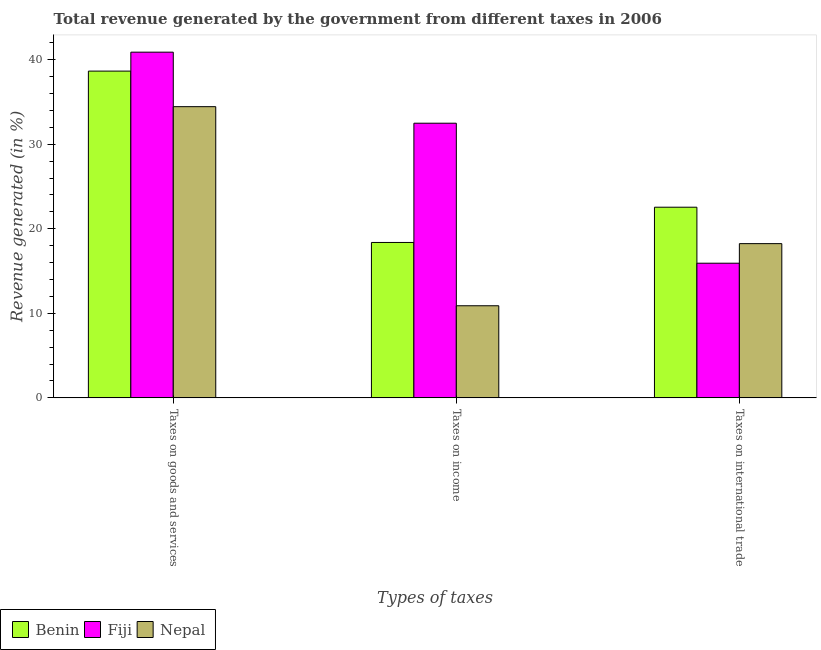How many groups of bars are there?
Your answer should be compact. 3. Are the number of bars per tick equal to the number of legend labels?
Make the answer very short. Yes. Are the number of bars on each tick of the X-axis equal?
Offer a very short reply. Yes. How many bars are there on the 1st tick from the right?
Give a very brief answer. 3. What is the label of the 2nd group of bars from the left?
Your answer should be compact. Taxes on income. What is the percentage of revenue generated by taxes on income in Fiji?
Keep it short and to the point. 32.49. Across all countries, what is the maximum percentage of revenue generated by taxes on income?
Your answer should be very brief. 32.49. Across all countries, what is the minimum percentage of revenue generated by tax on international trade?
Your answer should be compact. 15.93. In which country was the percentage of revenue generated by tax on international trade maximum?
Your answer should be very brief. Benin. In which country was the percentage of revenue generated by taxes on income minimum?
Your answer should be very brief. Nepal. What is the total percentage of revenue generated by taxes on income in the graph?
Provide a short and direct response. 61.76. What is the difference between the percentage of revenue generated by tax on international trade in Nepal and that in Benin?
Provide a short and direct response. -4.31. What is the difference between the percentage of revenue generated by tax on international trade in Nepal and the percentage of revenue generated by taxes on income in Fiji?
Keep it short and to the point. -14.24. What is the average percentage of revenue generated by taxes on goods and services per country?
Provide a short and direct response. 38. What is the difference between the percentage of revenue generated by tax on international trade and percentage of revenue generated by taxes on income in Nepal?
Provide a succinct answer. 7.35. What is the ratio of the percentage of revenue generated by taxes on goods and services in Fiji to that in Nepal?
Give a very brief answer. 1.19. Is the difference between the percentage of revenue generated by tax on international trade in Fiji and Nepal greater than the difference between the percentage of revenue generated by taxes on income in Fiji and Nepal?
Your answer should be very brief. No. What is the difference between the highest and the second highest percentage of revenue generated by taxes on income?
Make the answer very short. 14.11. What is the difference between the highest and the lowest percentage of revenue generated by taxes on goods and services?
Ensure brevity in your answer.  6.45. What does the 1st bar from the left in Taxes on goods and services represents?
Your answer should be compact. Benin. What does the 1st bar from the right in Taxes on income represents?
Offer a terse response. Nepal. Is it the case that in every country, the sum of the percentage of revenue generated by taxes on goods and services and percentage of revenue generated by taxes on income is greater than the percentage of revenue generated by tax on international trade?
Provide a succinct answer. Yes. How many bars are there?
Your response must be concise. 9. What is the difference between two consecutive major ticks on the Y-axis?
Make the answer very short. 10. Are the values on the major ticks of Y-axis written in scientific E-notation?
Provide a short and direct response. No. Does the graph contain any zero values?
Your response must be concise. No. Where does the legend appear in the graph?
Ensure brevity in your answer.  Bottom left. How many legend labels are there?
Give a very brief answer. 3. What is the title of the graph?
Offer a terse response. Total revenue generated by the government from different taxes in 2006. What is the label or title of the X-axis?
Your answer should be compact. Types of taxes. What is the label or title of the Y-axis?
Keep it short and to the point. Revenue generated (in %). What is the Revenue generated (in %) in Benin in Taxes on goods and services?
Provide a short and direct response. 38.65. What is the Revenue generated (in %) of Fiji in Taxes on goods and services?
Keep it short and to the point. 40.89. What is the Revenue generated (in %) in Nepal in Taxes on goods and services?
Offer a very short reply. 34.45. What is the Revenue generated (in %) in Benin in Taxes on income?
Make the answer very short. 18.38. What is the Revenue generated (in %) of Fiji in Taxes on income?
Keep it short and to the point. 32.49. What is the Revenue generated (in %) in Nepal in Taxes on income?
Your answer should be very brief. 10.89. What is the Revenue generated (in %) in Benin in Taxes on international trade?
Provide a succinct answer. 22.55. What is the Revenue generated (in %) of Fiji in Taxes on international trade?
Provide a short and direct response. 15.93. What is the Revenue generated (in %) of Nepal in Taxes on international trade?
Offer a very short reply. 18.24. Across all Types of taxes, what is the maximum Revenue generated (in %) in Benin?
Ensure brevity in your answer.  38.65. Across all Types of taxes, what is the maximum Revenue generated (in %) in Fiji?
Your response must be concise. 40.89. Across all Types of taxes, what is the maximum Revenue generated (in %) of Nepal?
Make the answer very short. 34.45. Across all Types of taxes, what is the minimum Revenue generated (in %) of Benin?
Ensure brevity in your answer.  18.38. Across all Types of taxes, what is the minimum Revenue generated (in %) in Fiji?
Keep it short and to the point. 15.93. Across all Types of taxes, what is the minimum Revenue generated (in %) in Nepal?
Make the answer very short. 10.89. What is the total Revenue generated (in %) in Benin in the graph?
Provide a succinct answer. 79.59. What is the total Revenue generated (in %) of Fiji in the graph?
Offer a terse response. 89.31. What is the total Revenue generated (in %) of Nepal in the graph?
Provide a succinct answer. 63.59. What is the difference between the Revenue generated (in %) of Benin in Taxes on goods and services and that in Taxes on income?
Make the answer very short. 20.27. What is the difference between the Revenue generated (in %) in Fiji in Taxes on goods and services and that in Taxes on income?
Offer a terse response. 8.41. What is the difference between the Revenue generated (in %) in Nepal in Taxes on goods and services and that in Taxes on income?
Provide a short and direct response. 23.55. What is the difference between the Revenue generated (in %) of Benin in Taxes on goods and services and that in Taxes on international trade?
Provide a succinct answer. 16.1. What is the difference between the Revenue generated (in %) in Fiji in Taxes on goods and services and that in Taxes on international trade?
Offer a terse response. 24.96. What is the difference between the Revenue generated (in %) of Nepal in Taxes on goods and services and that in Taxes on international trade?
Keep it short and to the point. 16.2. What is the difference between the Revenue generated (in %) of Benin in Taxes on income and that in Taxes on international trade?
Ensure brevity in your answer.  -4.17. What is the difference between the Revenue generated (in %) of Fiji in Taxes on income and that in Taxes on international trade?
Your response must be concise. 16.56. What is the difference between the Revenue generated (in %) in Nepal in Taxes on income and that in Taxes on international trade?
Your response must be concise. -7.35. What is the difference between the Revenue generated (in %) in Benin in Taxes on goods and services and the Revenue generated (in %) in Fiji in Taxes on income?
Your answer should be very brief. 6.17. What is the difference between the Revenue generated (in %) of Benin in Taxes on goods and services and the Revenue generated (in %) of Nepal in Taxes on income?
Give a very brief answer. 27.76. What is the difference between the Revenue generated (in %) of Fiji in Taxes on goods and services and the Revenue generated (in %) of Nepal in Taxes on income?
Your answer should be very brief. 30. What is the difference between the Revenue generated (in %) in Benin in Taxes on goods and services and the Revenue generated (in %) in Fiji in Taxes on international trade?
Make the answer very short. 22.72. What is the difference between the Revenue generated (in %) of Benin in Taxes on goods and services and the Revenue generated (in %) of Nepal in Taxes on international trade?
Keep it short and to the point. 20.41. What is the difference between the Revenue generated (in %) of Fiji in Taxes on goods and services and the Revenue generated (in %) of Nepal in Taxes on international trade?
Provide a short and direct response. 22.65. What is the difference between the Revenue generated (in %) of Benin in Taxes on income and the Revenue generated (in %) of Fiji in Taxes on international trade?
Make the answer very short. 2.45. What is the difference between the Revenue generated (in %) of Benin in Taxes on income and the Revenue generated (in %) of Nepal in Taxes on international trade?
Offer a terse response. 0.14. What is the difference between the Revenue generated (in %) in Fiji in Taxes on income and the Revenue generated (in %) in Nepal in Taxes on international trade?
Offer a terse response. 14.24. What is the average Revenue generated (in %) in Benin per Types of taxes?
Offer a terse response. 26.53. What is the average Revenue generated (in %) of Fiji per Types of taxes?
Ensure brevity in your answer.  29.77. What is the average Revenue generated (in %) in Nepal per Types of taxes?
Make the answer very short. 21.2. What is the difference between the Revenue generated (in %) in Benin and Revenue generated (in %) in Fiji in Taxes on goods and services?
Offer a very short reply. -2.24. What is the difference between the Revenue generated (in %) of Benin and Revenue generated (in %) of Nepal in Taxes on goods and services?
Provide a succinct answer. 4.21. What is the difference between the Revenue generated (in %) in Fiji and Revenue generated (in %) in Nepal in Taxes on goods and services?
Make the answer very short. 6.45. What is the difference between the Revenue generated (in %) in Benin and Revenue generated (in %) in Fiji in Taxes on income?
Your answer should be very brief. -14.11. What is the difference between the Revenue generated (in %) in Benin and Revenue generated (in %) in Nepal in Taxes on income?
Provide a short and direct response. 7.49. What is the difference between the Revenue generated (in %) in Fiji and Revenue generated (in %) in Nepal in Taxes on income?
Give a very brief answer. 21.59. What is the difference between the Revenue generated (in %) in Benin and Revenue generated (in %) in Fiji in Taxes on international trade?
Ensure brevity in your answer.  6.62. What is the difference between the Revenue generated (in %) in Benin and Revenue generated (in %) in Nepal in Taxes on international trade?
Offer a terse response. 4.31. What is the difference between the Revenue generated (in %) in Fiji and Revenue generated (in %) in Nepal in Taxes on international trade?
Keep it short and to the point. -2.32. What is the ratio of the Revenue generated (in %) of Benin in Taxes on goods and services to that in Taxes on income?
Provide a short and direct response. 2.1. What is the ratio of the Revenue generated (in %) in Fiji in Taxes on goods and services to that in Taxes on income?
Ensure brevity in your answer.  1.26. What is the ratio of the Revenue generated (in %) in Nepal in Taxes on goods and services to that in Taxes on income?
Your answer should be compact. 3.16. What is the ratio of the Revenue generated (in %) in Benin in Taxes on goods and services to that in Taxes on international trade?
Give a very brief answer. 1.71. What is the ratio of the Revenue generated (in %) in Fiji in Taxes on goods and services to that in Taxes on international trade?
Make the answer very short. 2.57. What is the ratio of the Revenue generated (in %) in Nepal in Taxes on goods and services to that in Taxes on international trade?
Offer a very short reply. 1.89. What is the ratio of the Revenue generated (in %) of Benin in Taxes on income to that in Taxes on international trade?
Your answer should be compact. 0.82. What is the ratio of the Revenue generated (in %) of Fiji in Taxes on income to that in Taxes on international trade?
Offer a terse response. 2.04. What is the ratio of the Revenue generated (in %) of Nepal in Taxes on income to that in Taxes on international trade?
Your response must be concise. 0.6. What is the difference between the highest and the second highest Revenue generated (in %) in Benin?
Offer a terse response. 16.1. What is the difference between the highest and the second highest Revenue generated (in %) in Fiji?
Provide a succinct answer. 8.41. What is the difference between the highest and the second highest Revenue generated (in %) in Nepal?
Provide a short and direct response. 16.2. What is the difference between the highest and the lowest Revenue generated (in %) in Benin?
Ensure brevity in your answer.  20.27. What is the difference between the highest and the lowest Revenue generated (in %) in Fiji?
Your answer should be compact. 24.96. What is the difference between the highest and the lowest Revenue generated (in %) of Nepal?
Offer a terse response. 23.55. 